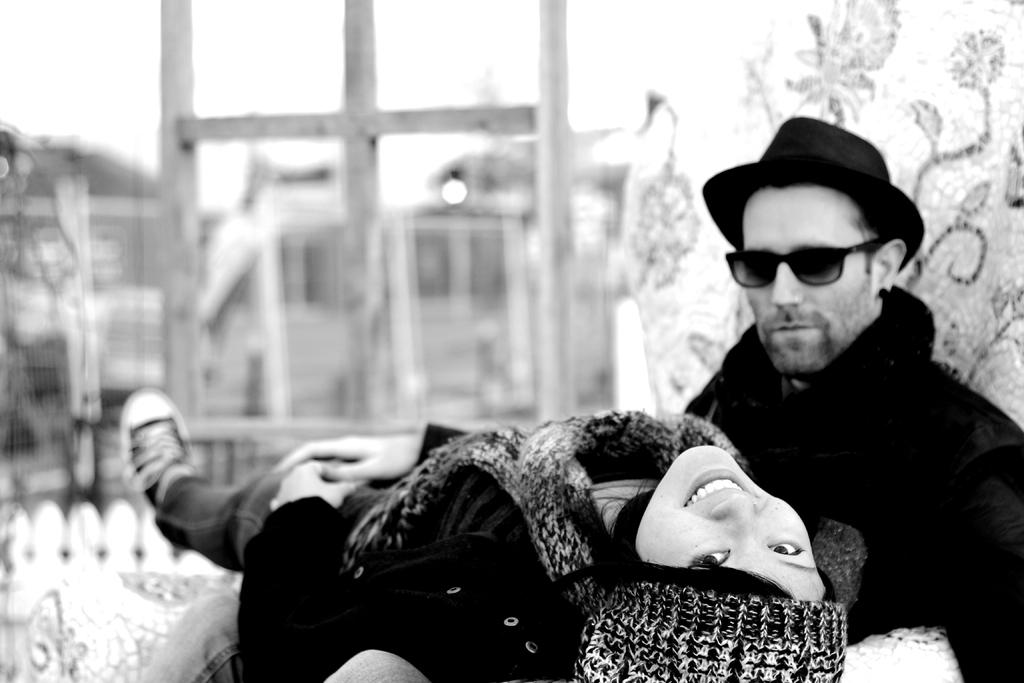How many people are in the image? There are two people in the image, a man and a woman. What are the people wearing on their heads? Both the man and the woman are wearing caps. What protective gear is the man wearing? The man is wearing goggles. Can you describe the background of the image? The background of the image is blurry. What type of pies are being served on the table in the image? There is no table or pies present in the image. What part of the brain can be seen in the image? There is no brain visible in the image. 